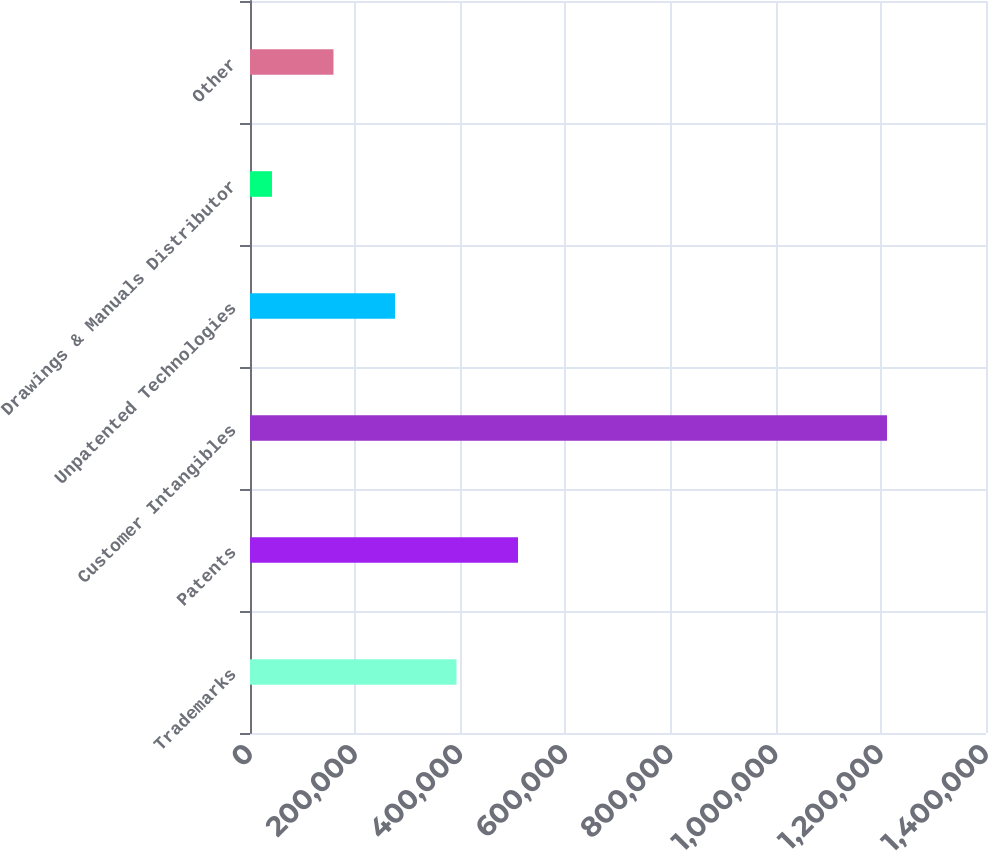Convert chart. <chart><loc_0><loc_0><loc_500><loc_500><bar_chart><fcel>Trademarks<fcel>Patents<fcel>Customer Intangibles<fcel>Unpatented Technologies<fcel>Drawings & Manuals Distributor<fcel>Other<nl><fcel>392783<fcel>509778<fcel>1.21174e+06<fcel>275789<fcel>41800<fcel>158794<nl></chart> 